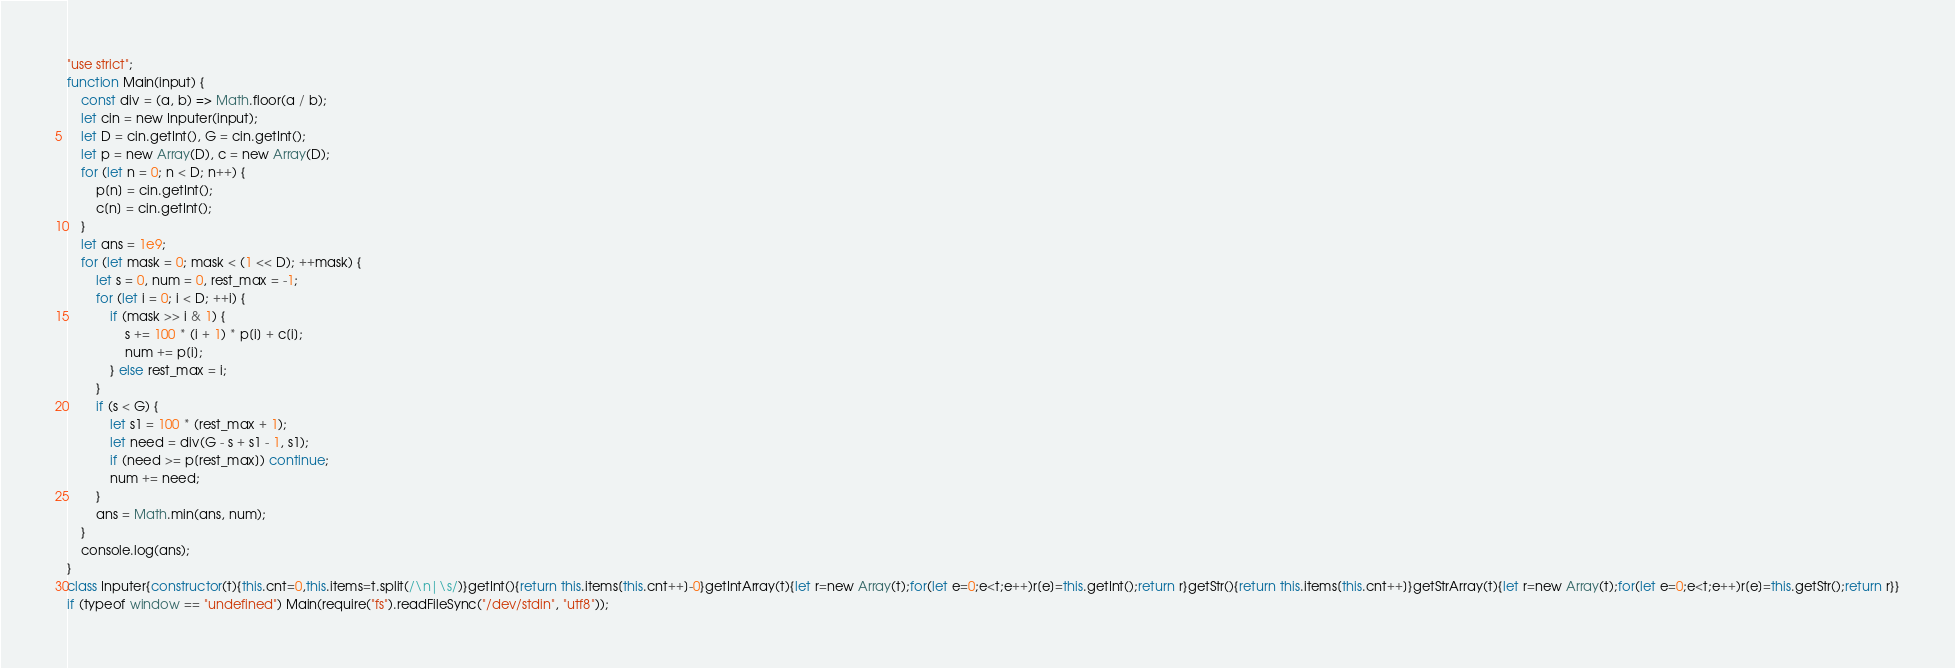<code> <loc_0><loc_0><loc_500><loc_500><_JavaScript_>"use strict";
function Main(input) {
    const div = (a, b) => Math.floor(a / b);
    let cin = new Inputer(input);
    let D = cin.getInt(), G = cin.getInt();
    let p = new Array(D), c = new Array(D);
    for (let n = 0; n < D; n++) {
        p[n] = cin.getInt();
        c[n] = cin.getInt();
    }
    let ans = 1e9;
    for (let mask = 0; mask < (1 << D); ++mask) {
        let s = 0, num = 0, rest_max = -1;
        for (let i = 0; i < D; ++i) {
            if (mask >> i & 1) {
                s += 100 * (i + 1) * p[i] + c[i];
                num += p[i];
            } else rest_max = i;
        }
        if (s < G) {
            let s1 = 100 * (rest_max + 1);
            let need = div(G - s + s1 - 1, s1);
            if (need >= p[rest_max]) continue;
            num += need;
        }
        ans = Math.min(ans, num);
    }
    console.log(ans);
}
class Inputer{constructor(t){this.cnt=0,this.items=t.split(/\n|\s/)}getInt(){return this.items[this.cnt++]-0}getIntArray(t){let r=new Array(t);for(let e=0;e<t;e++)r[e]=this.getInt();return r}getStr(){return this.items[this.cnt++]}getStrArray(t){let r=new Array(t);for(let e=0;e<t;e++)r[e]=this.getStr();return r}}
if (typeof window == "undefined") Main(require("fs").readFileSync("/dev/stdin", "utf8"));
</code> 